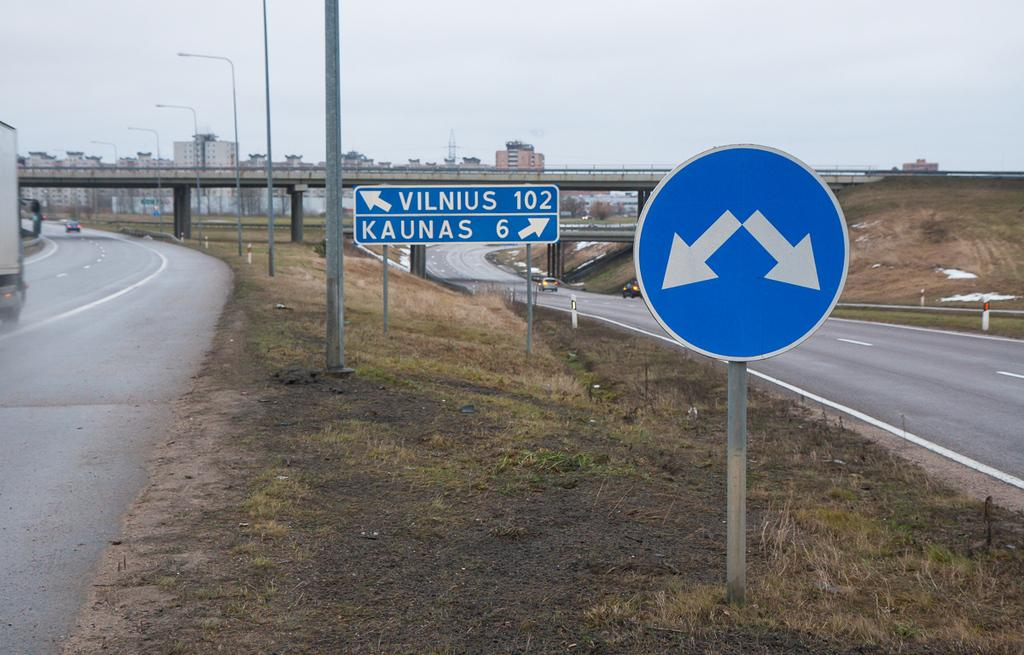Provide a one-sentence caption for the provided image. Two roads, one of which goes to Vilnus and the other which goes to Kaunas. 